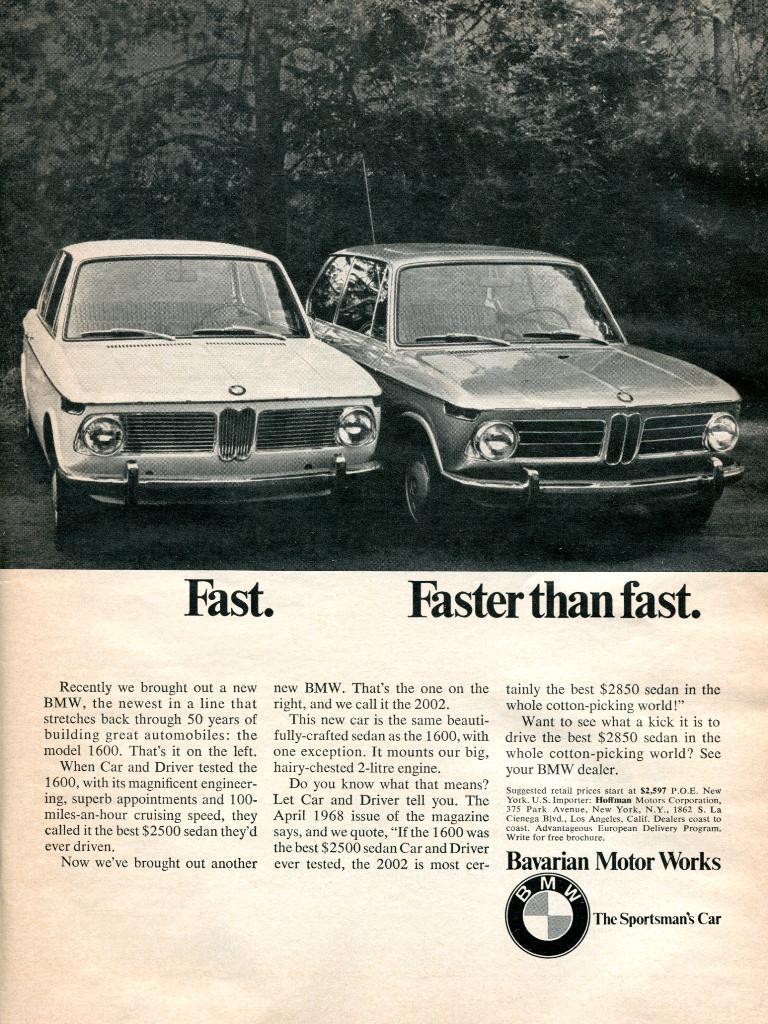Can you describe this image briefly? There is a poster in which, there is a image. In the image, there are two vehicles parked on the grass on the ground. In the background, there are trees. Below this image, there are texts and watermark on the white page. 